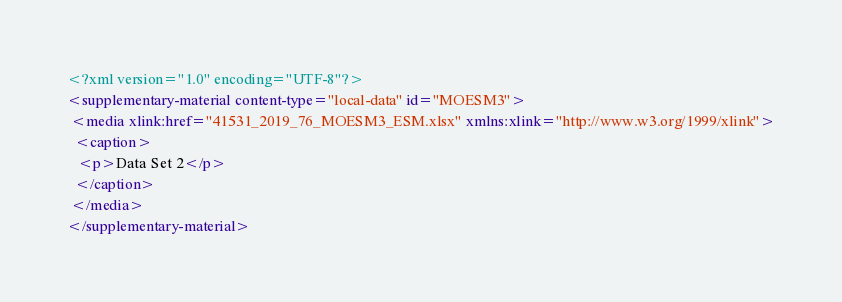Convert code to text. <code><loc_0><loc_0><loc_500><loc_500><_XML_><?xml version="1.0" encoding="UTF-8"?>
<supplementary-material content-type="local-data" id="MOESM3">
 <media xlink:href="41531_2019_76_MOESM3_ESM.xlsx" xmlns:xlink="http://www.w3.org/1999/xlink">
  <caption>
   <p>Data Set 2</p>
  </caption>
 </media>
</supplementary-material>
</code> 